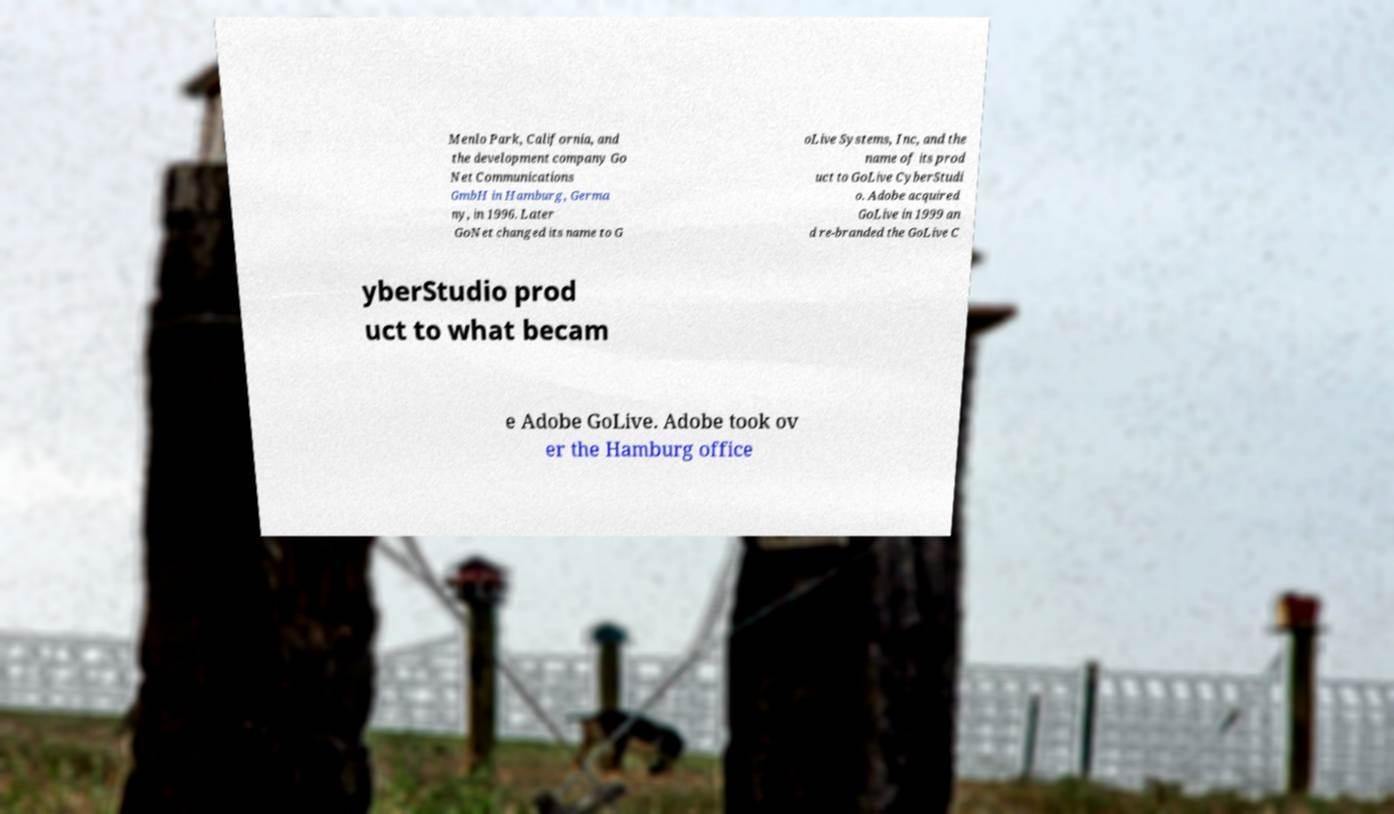Could you extract and type out the text from this image? Menlo Park, California, and the development company Go Net Communications GmbH in Hamburg, Germa ny, in 1996. Later GoNet changed its name to G oLive Systems, Inc, and the name of its prod uct to GoLive CyberStudi o. Adobe acquired GoLive in 1999 an d re-branded the GoLive C yberStudio prod uct to what becam e Adobe GoLive. Adobe took ov er the Hamburg office 